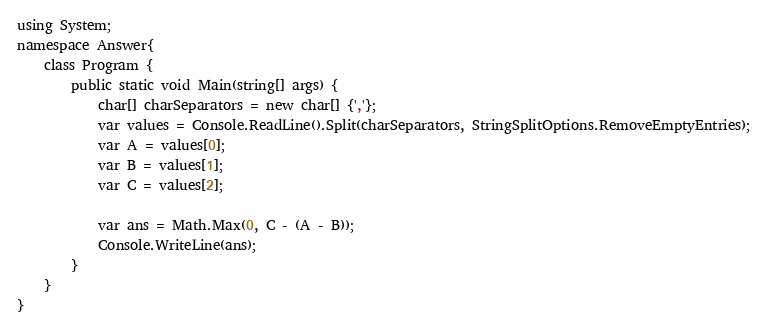Convert code to text. <code><loc_0><loc_0><loc_500><loc_500><_C#_>using System;
namespace Answer{
	class Program {
  		public static void Main(string[] args) {
            char[] charSeparators = new char[] {','};
    		var values = Console.ReadLine().Split(charSeparators, StringSplitOptions.RemoveEmptyEntries);
    		var A = values[0];
    		var B = values[1];
    		var C = values[2];
    
    		var ans = Math.Max(0, C - (A - B));
    		Console.WriteLine(ans);
  		}
	}
}

</code> 